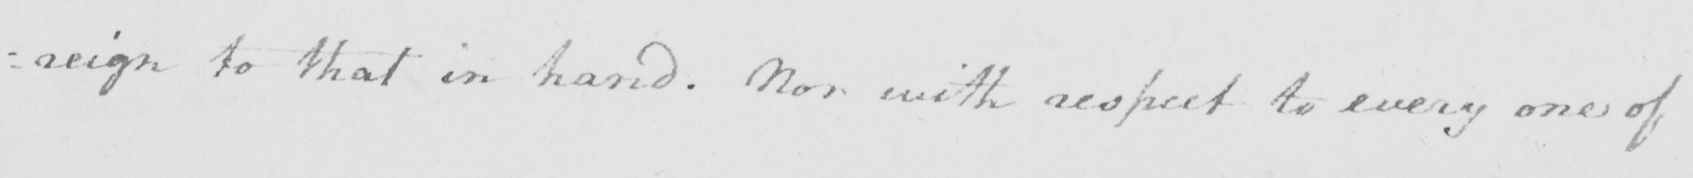Please provide the text content of this handwritten line. : reign to that in hand . Nor with respect to every one of 